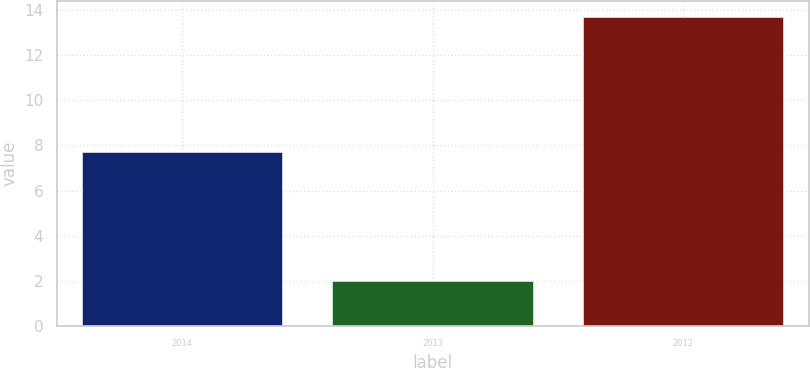Convert chart to OTSL. <chart><loc_0><loc_0><loc_500><loc_500><bar_chart><fcel>2014<fcel>2013<fcel>2012<nl><fcel>7.7<fcel>2<fcel>13.7<nl></chart> 